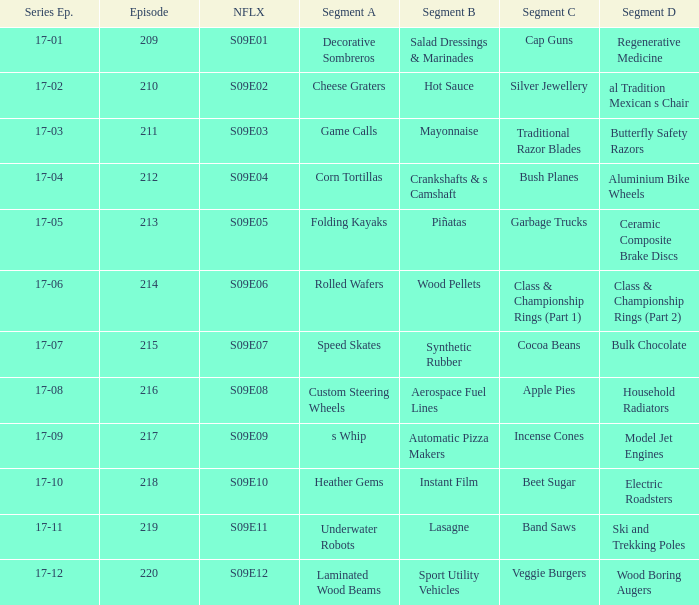Are rolled wafers in many episodes 17-06. 